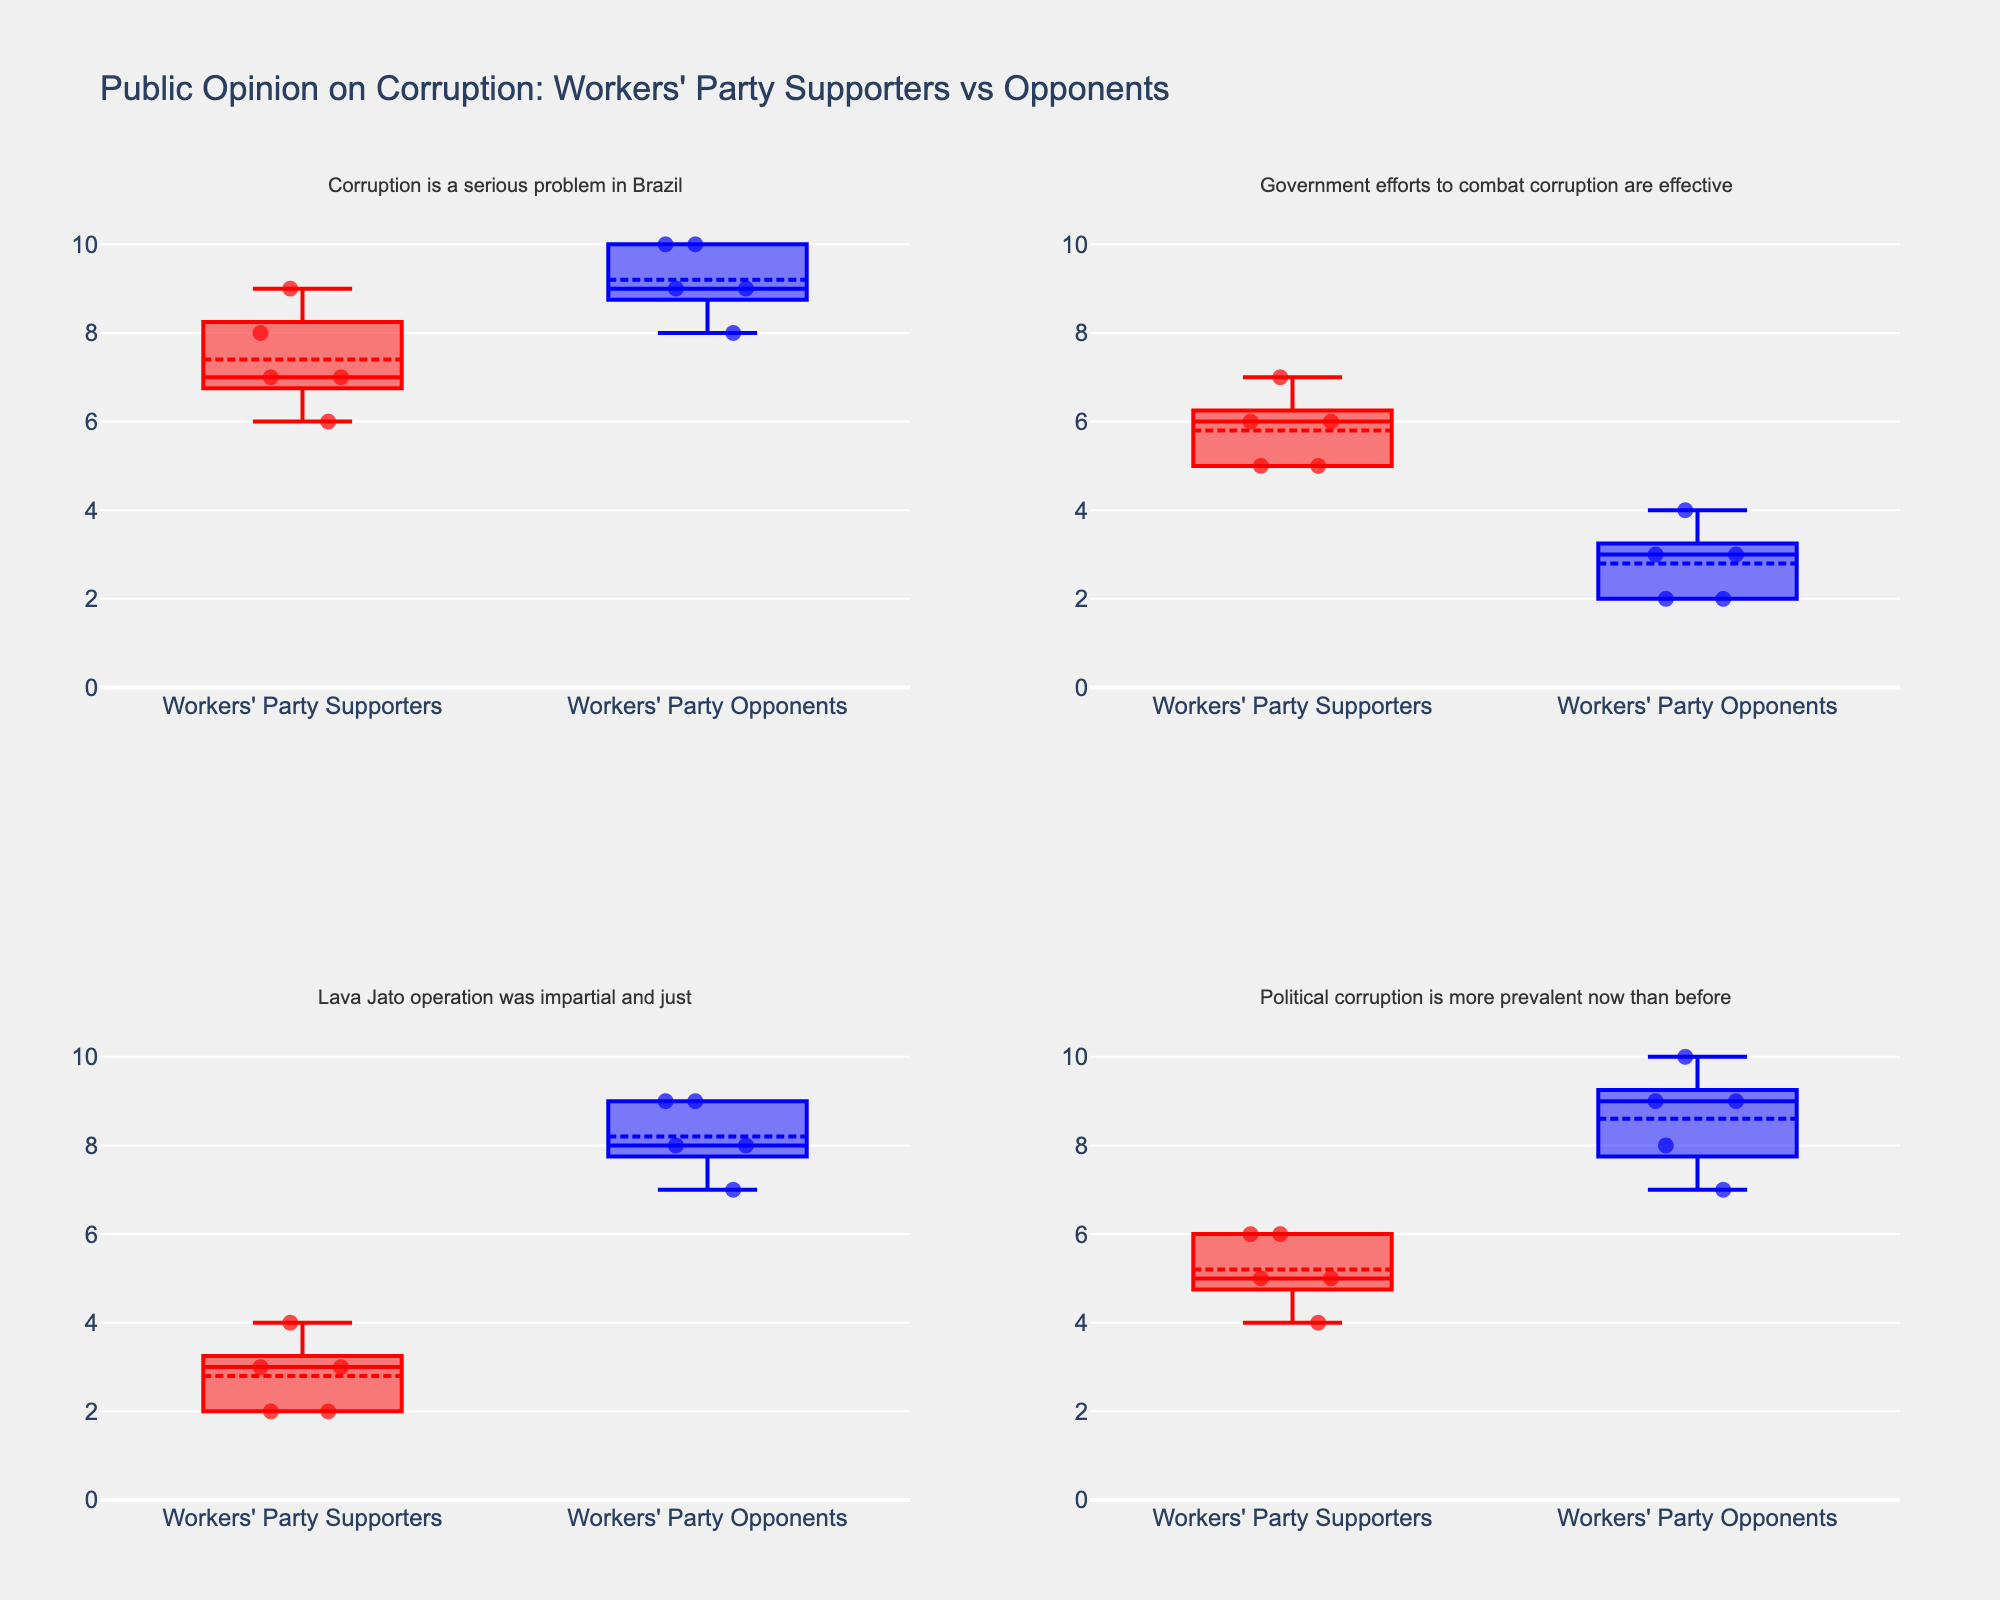What is the title of the plot? The title is usually found at the top of the figure, indicating what the plot is about. In this case, it mentions a comparison of the public opinion on corruption between supporters and opponents of the Workers' Party.
Answer: Public Opinion on Corruption: Workers' Party Supporters vs Opponents How many subplots are there in the figure? The figure is described as having multiple subplots, each with its own question about corruption. There are 4 unique questions, implying there are 4 subplots.
Answer: 4 Which group has the higher median rating for the question "Corruption is a serious problem in Brazil"? In the box plot, the median is represented by the line inside each box. For "Corruption is a serious problem in Brazil", compare the medians of the red and blue boxes. The median for Workers' Party Opponents (blue) is higher.
Answer: Workers' Party Opponents What are the quartile ranges for the ratings given by Workers' Party Supporters and Opponents regarding "Lava Jato operation was impartial and just"? In the box plot, the quartile ranges are the spread of the box's lower and upper boundaries (Q1 and Q3). The ratings for Workers' Party Supporters range from 2 to 3 (Q1 to Q3) and Workers' Party Opponents from 7 to 9.
Answer: Supporters: 2-3, Opponents: 7-9 What is the common feature of the y-axes across all subplots? The y-axes on all subplots usually have the same range and tick values to maintain consistency for comparison. The given y-axis ranges from 0 to 11 with ticks at every 2 units.
Answer: Range: 0-11, Ticks: every 2 units Which group has more outliers in the rating for "Government efforts to combat corruption are effective"? Outliers are often represented by individual points outside the whiskers of the box plot. Compare the number of such points for both groups. Workers' Party Opponents (blue) have more outliers.
Answer: Workers' Party Opponents For the question "Political corruption is more prevalent now than before", what can you infer about the skewness of the distributions for both groups? Skewness can be inferred from the asymmetry of the box plot. A longer whisker or concentration of points on one side indicates skewness. For Workers' Party Supporters (red), the box is relatively symmetrical; for Workers' Party Opponents (blue), it is skewed left as the median is closer to the lower quartile.
Answer: Supporters: Symmetrical, Opponents: Skewed left Is the general perception of government efforts to combat corruption more negative among Workers' Party supporters or opponents? This can be inferred by comparing the central tendencies (medians) in the box plots. A lower median rating indicates a more negative perception. Workers' Party Opponents have a lower median for this question, indicating a more negative perception.
Answer: Workers' Party Opponents How do the means compare for the question "Corruption is a serious problem in Brazil"? The means in a box plot with boxmean=True are marked by a specific point (often a dot). Compare these means for the red and blue boxes. The mean rating for Workers' Party Opponents (blue) is higher than that for supporters.
Answer: Opponents have a higher mean Based on all subplots, which group generally gives higher ratings for the questions related to corruption being a serious problem and political corruption prevalence? By comparing the central tendencies (medians, means) and spread (quartiles) in the box plots for questions about corruption severity and prevalence, we observe that Workers' Party Opponents generally give higher ratings.
Answer: Workers' Party Opponents 